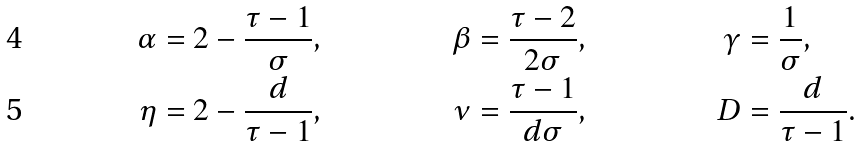<formula> <loc_0><loc_0><loc_500><loc_500>\alpha & = 2 - \frac { \tau - 1 } { \sigma } , & \beta & = \frac { \tau - 2 } { 2 \sigma } , & \gamma & = \frac { 1 } { \sigma } , \\ \eta & = 2 - \frac { d } { \tau - 1 } , & \nu & = \frac { \tau - 1 } { d \sigma } , & D & = \frac { d } { \tau - 1 } .</formula> 